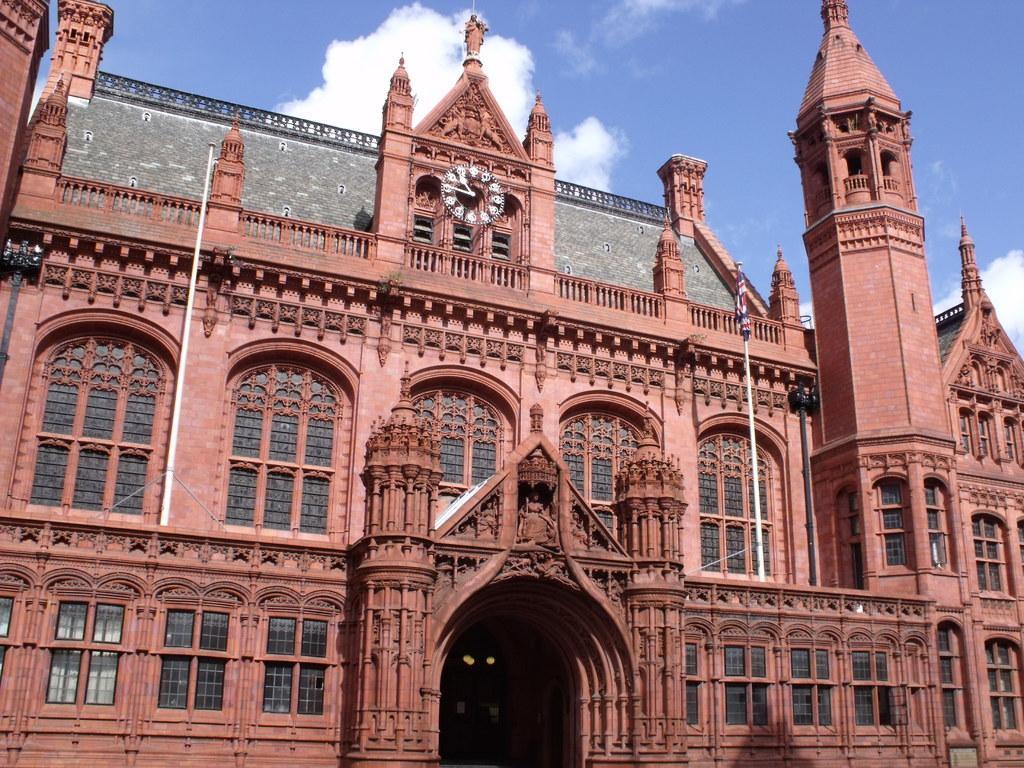How would you summarize this image in a sentence or two? In this image there is the sky towards the top of the image, there are clouds in the sky, there is a building, there is a wall clock on the building, there are poles, there is a flag, there are windows. 